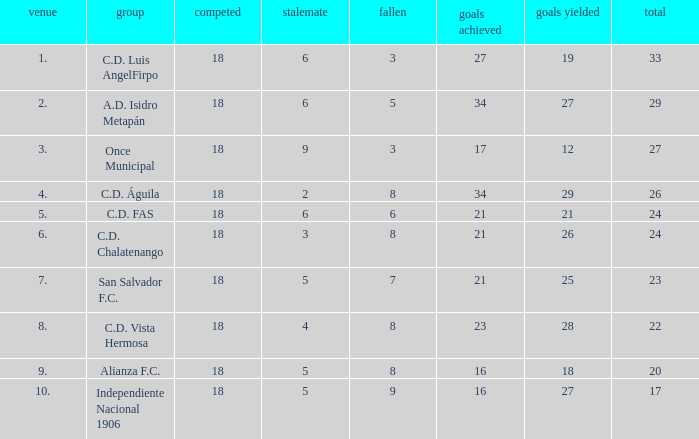What were the goal conceded that had a lost greater than 8 and more than 17 points? None. 